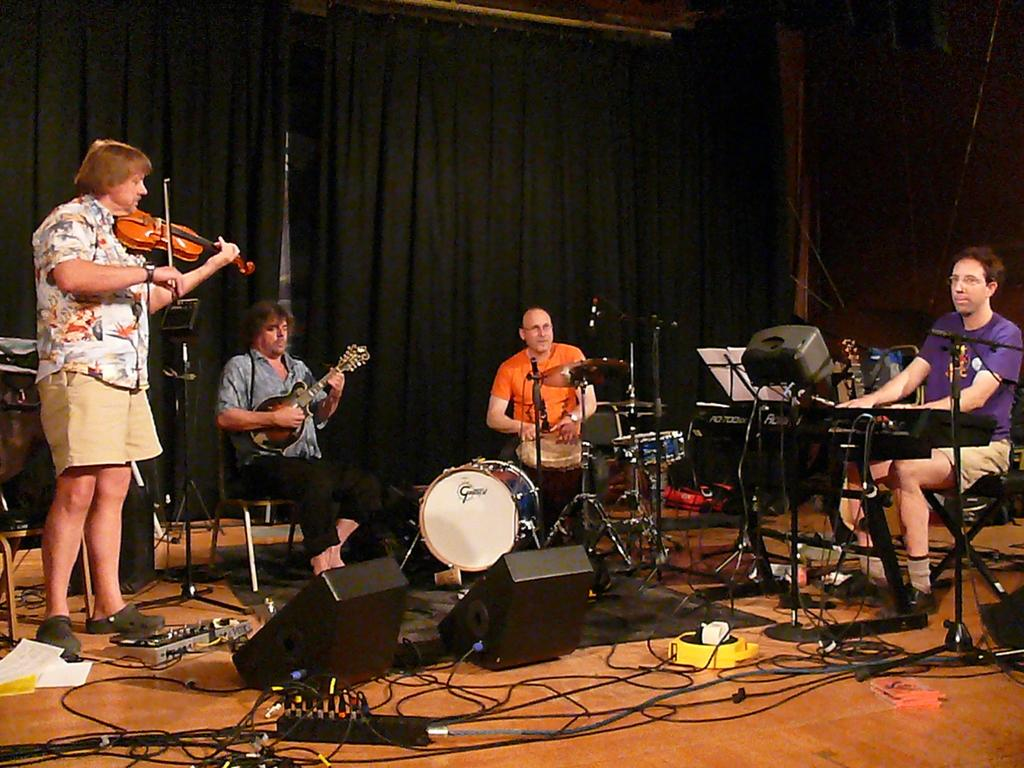How many people are present in the image? There are four people in the image. What are the positions of the people in the image? One person is standing, while the rest are sitting. What can be seen in the background of the image? There are curtains in the image. What object is visible in the image that is commonly associated with music? There is a guitar in the image. What are the people in the image doing? The people are playing musical instruments. What type of bag is being used to carry the guitar in the image? There is no bag present in the image, and the guitar is not being carried. 